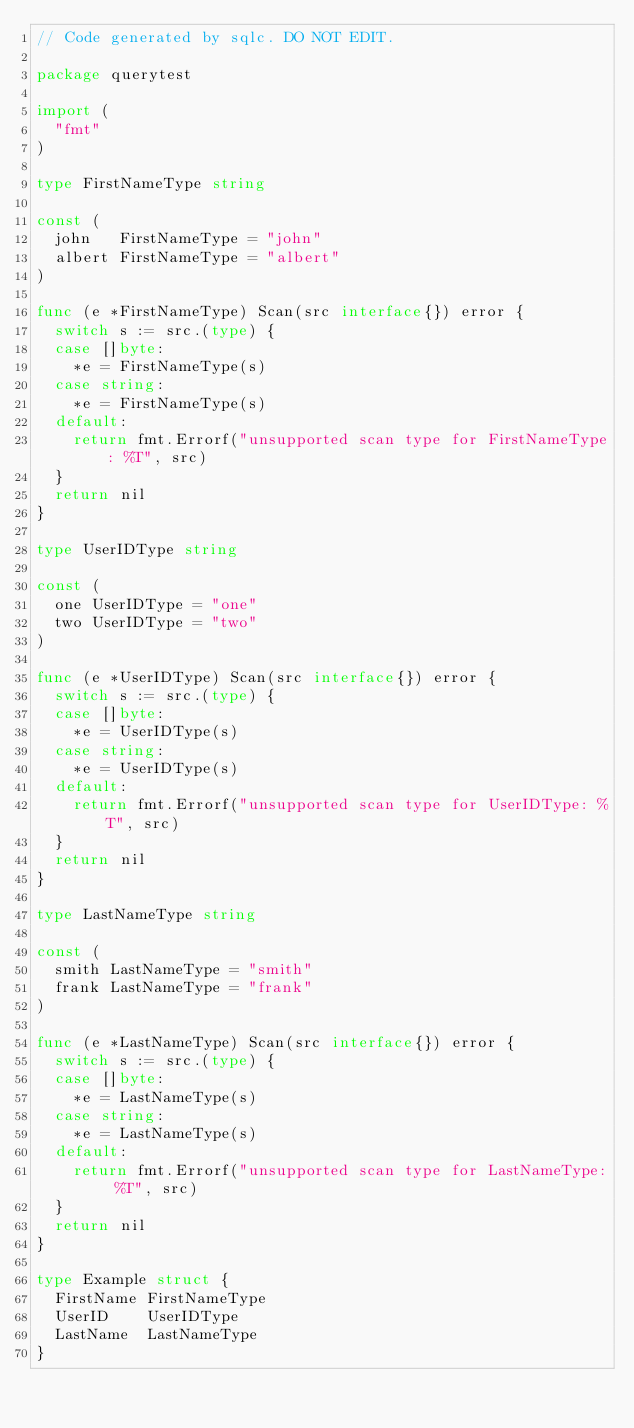Convert code to text. <code><loc_0><loc_0><loc_500><loc_500><_Go_>// Code generated by sqlc. DO NOT EDIT.

package querytest

import (
	"fmt"
)

type FirstNameType string

const (
	john   FirstNameType = "john"
	albert FirstNameType = "albert"
)

func (e *FirstNameType) Scan(src interface{}) error {
	switch s := src.(type) {
	case []byte:
		*e = FirstNameType(s)
	case string:
		*e = FirstNameType(s)
	default:
		return fmt.Errorf("unsupported scan type for FirstNameType: %T", src)
	}
	return nil
}

type UserIDType string

const (
	one UserIDType = "one"
	two UserIDType = "two"
)

func (e *UserIDType) Scan(src interface{}) error {
	switch s := src.(type) {
	case []byte:
		*e = UserIDType(s)
	case string:
		*e = UserIDType(s)
	default:
		return fmt.Errorf("unsupported scan type for UserIDType: %T", src)
	}
	return nil
}

type LastNameType string

const (
	smith LastNameType = "smith"
	frank LastNameType = "frank"
)

func (e *LastNameType) Scan(src interface{}) error {
	switch s := src.(type) {
	case []byte:
		*e = LastNameType(s)
	case string:
		*e = LastNameType(s)
	default:
		return fmt.Errorf("unsupported scan type for LastNameType: %T", src)
	}
	return nil
}

type Example struct {
	FirstName FirstNameType
	UserID    UserIDType
	LastName  LastNameType
}
</code> 